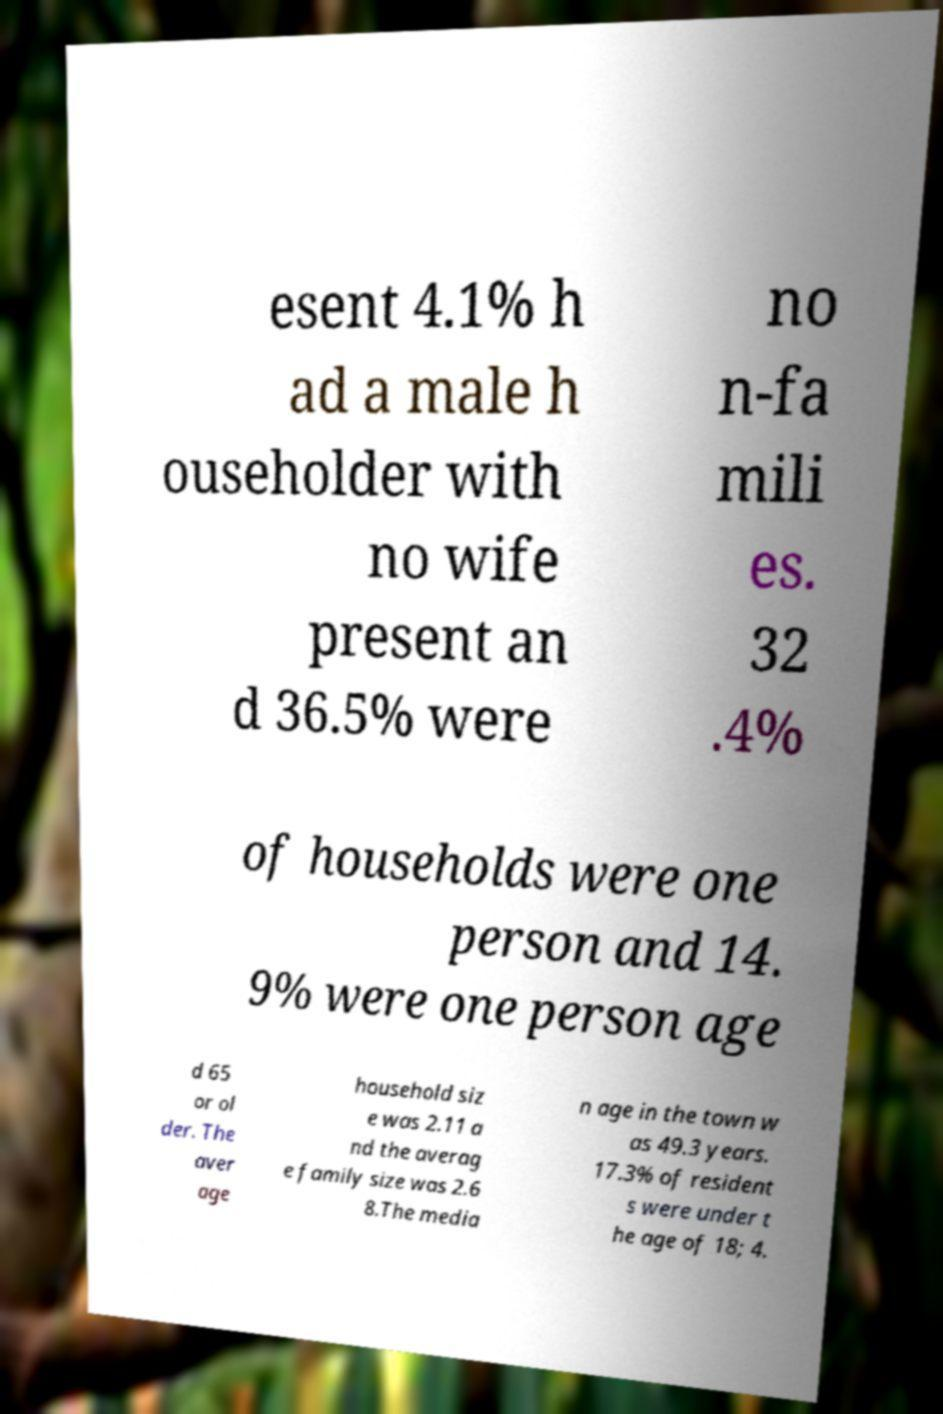There's text embedded in this image that I need extracted. Can you transcribe it verbatim? esent 4.1% h ad a male h ouseholder with no wife present an d 36.5% were no n-fa mili es. 32 .4% of households were one person and 14. 9% were one person age d 65 or ol der. The aver age household siz e was 2.11 a nd the averag e family size was 2.6 8.The media n age in the town w as 49.3 years. 17.3% of resident s were under t he age of 18; 4. 